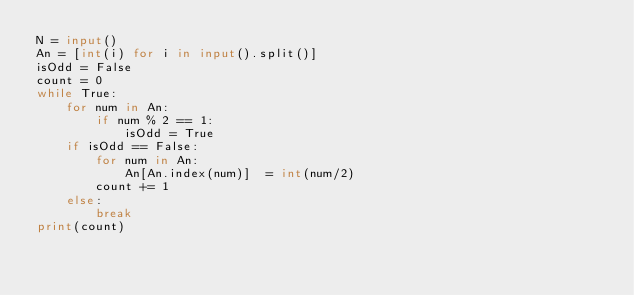<code> <loc_0><loc_0><loc_500><loc_500><_Python_>N = input()
An = [int(i) for i in input().split()]
isOdd = False
count = 0
while True:
    for num in An:
        if num % 2 == 1:
            isOdd = True
    if isOdd == False:
        for num in An:
            An[An.index(num)]  = int(num/2)
        count += 1
    else:
        break
print(count)
</code> 